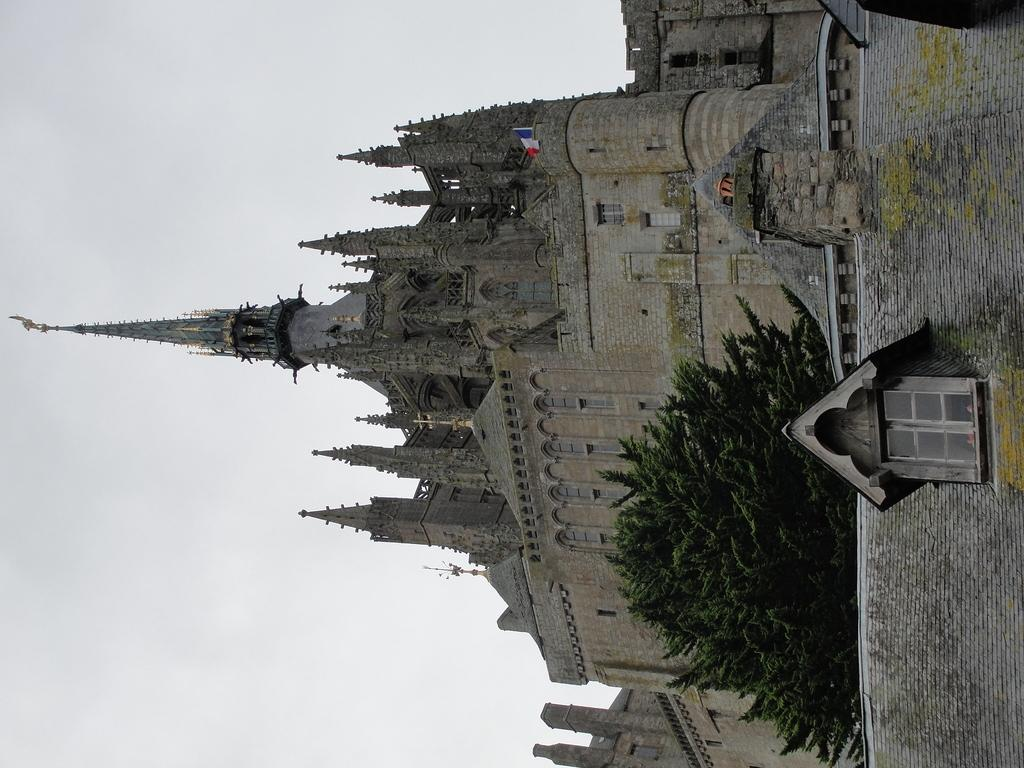What is the main structure in the center of the image? There is a building in the center of the image. What additional feature can be seen in the image? There is a flag in the image. What type of plant is present in the image? There is a tree in the image. What can be seen in the background of the image? The sky is visible in the background of the image. What type of oil is being used to fuel the building in the image? There is no indication of any oil being used to fuel the building in the image. 